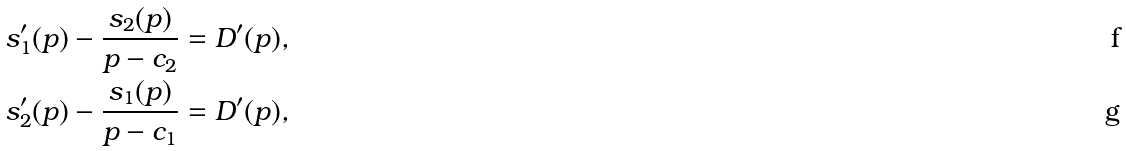Convert formula to latex. <formula><loc_0><loc_0><loc_500><loc_500>s _ { 1 } ^ { \prime } ( p ) - \frac { s _ { 2 } ( p ) } { p - c _ { 2 } } & = D ^ { \prime } ( p ) , \\ s _ { 2 } ^ { \prime } ( p ) - \frac { s _ { 1 } ( p ) } { p - c _ { 1 } } & = D ^ { \prime } ( p ) ,</formula> 